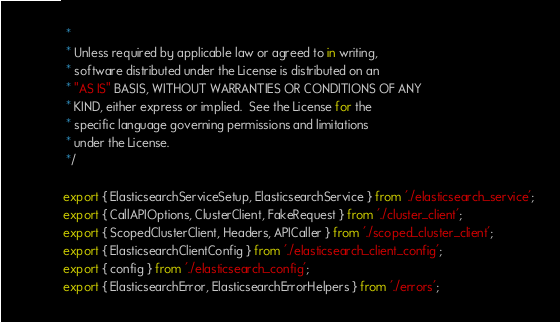<code> <loc_0><loc_0><loc_500><loc_500><_TypeScript_> *
 * Unless required by applicable law or agreed to in writing,
 * software distributed under the License is distributed on an
 * "AS IS" BASIS, WITHOUT WARRANTIES OR CONDITIONS OF ANY
 * KIND, either express or implied.  See the License for the
 * specific language governing permissions and limitations
 * under the License.
 */

export { ElasticsearchServiceSetup, ElasticsearchService } from './elasticsearch_service';
export { CallAPIOptions, ClusterClient, FakeRequest } from './cluster_client';
export { ScopedClusterClient, Headers, APICaller } from './scoped_cluster_client';
export { ElasticsearchClientConfig } from './elasticsearch_client_config';
export { config } from './elasticsearch_config';
export { ElasticsearchError, ElasticsearchErrorHelpers } from './errors';
</code> 